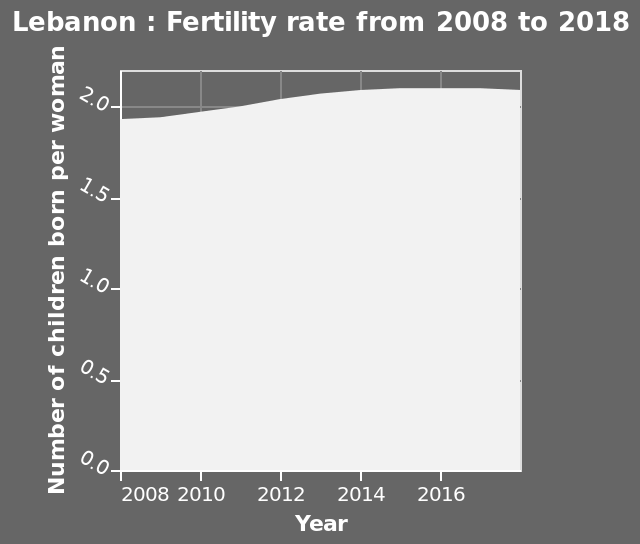<image>
What is the year with the least number of children born per woman?  The year with the least number of children born per woman is 2018. Is the fertility rate higher in 2018 compared to 2008? Yes, the fertility rate is higher in 2018 compared to 2008. What is the name of the area graph? The name of the area graph is "Lebanon : Fertility rate from 2008 to 2018." What does the y-axis measure? The y-axis measures the "Number of children born per woman" on the graph. please describe the details of the chart Here a is a area graph called Lebanon : Fertility rate from 2008 to 2018. The x-axis plots Year using linear scale of range 2008 to 2016 while the y-axis measures Number of children born per woman using linear scale with a minimum of 0.0 and a maximum of 2.0. please summary the statistics and relations of the chart The fertility rate seems to be increasing between 2008 and 2018, with the year 2018 being the year with the least number of children born per woman. 